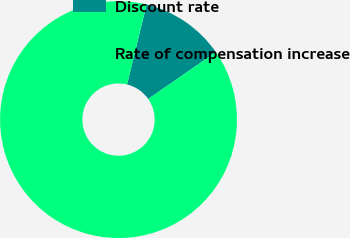<chart> <loc_0><loc_0><loc_500><loc_500><pie_chart><fcel>Discount rate<fcel>Rate of compensation increase<nl><fcel>11.54%<fcel>88.46%<nl></chart> 